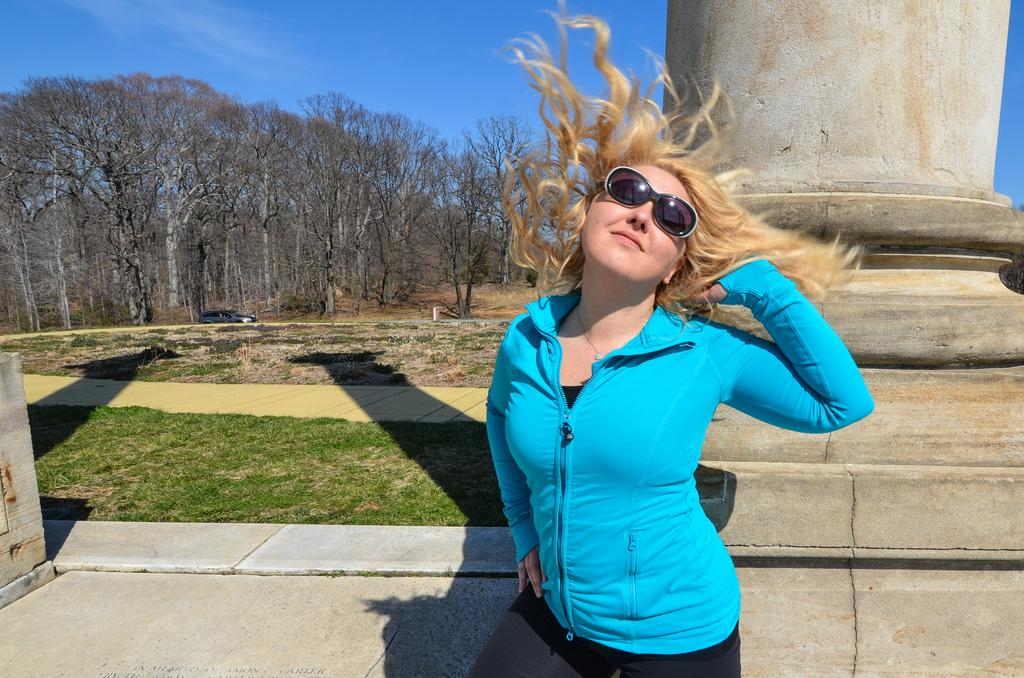Who is present in the image? There is a woman in the image. What is the woman wearing on her face? The woman is wearing goggles. What can be seen in the background of the image? There is a pillar, a car on the road, grass, trees, and the sky visible in the background of the image. How many metal brushes are visible in the image? There are no metal brushes present in the image. 